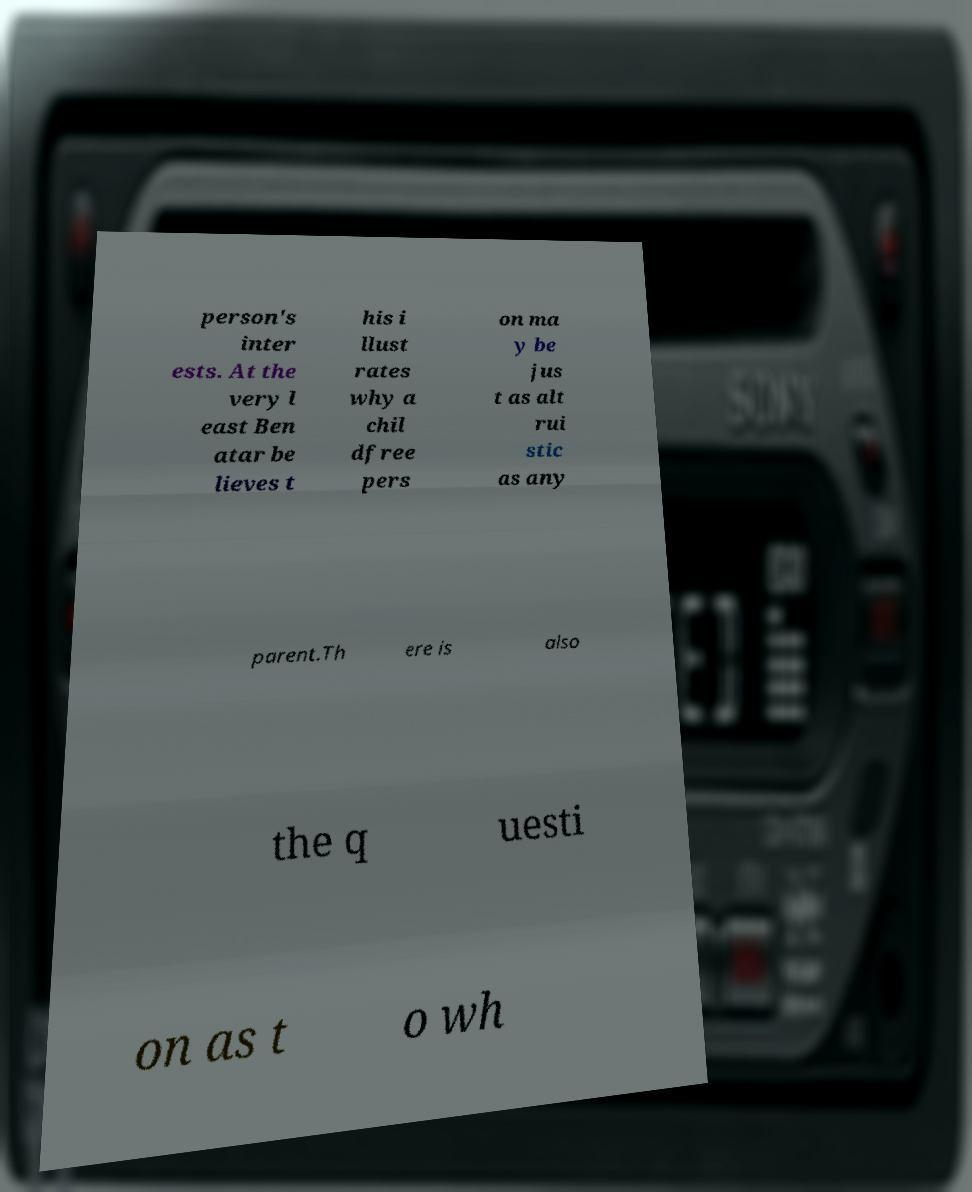Could you assist in decoding the text presented in this image and type it out clearly? person's inter ests. At the very l east Ben atar be lieves t his i llust rates why a chil dfree pers on ma y be jus t as alt rui stic as any parent.Th ere is also the q uesti on as t o wh 